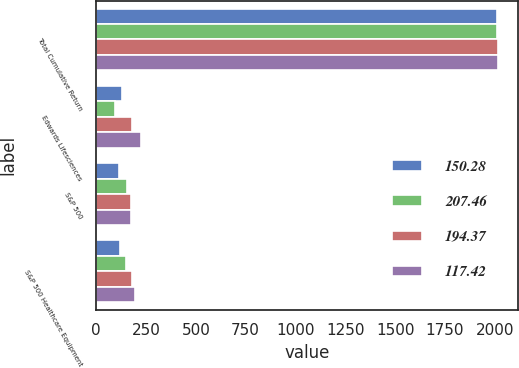<chart> <loc_0><loc_0><loc_500><loc_500><stacked_bar_chart><ecel><fcel>Total Cumulative Return<fcel>Edwards Lifesciences<fcel>S&P 500<fcel>S&P 500 Healthcare Equipment<nl><fcel>150.28<fcel>2012<fcel>127.54<fcel>116<fcel>117.42<nl><fcel>207.46<fcel>2013<fcel>93.01<fcel>153.58<fcel>150.28<nl><fcel>194.37<fcel>2014<fcel>180.17<fcel>174.6<fcel>181.96<nl><fcel>117.42<fcel>2015<fcel>223.42<fcel>177.01<fcel>194.37<nl></chart> 